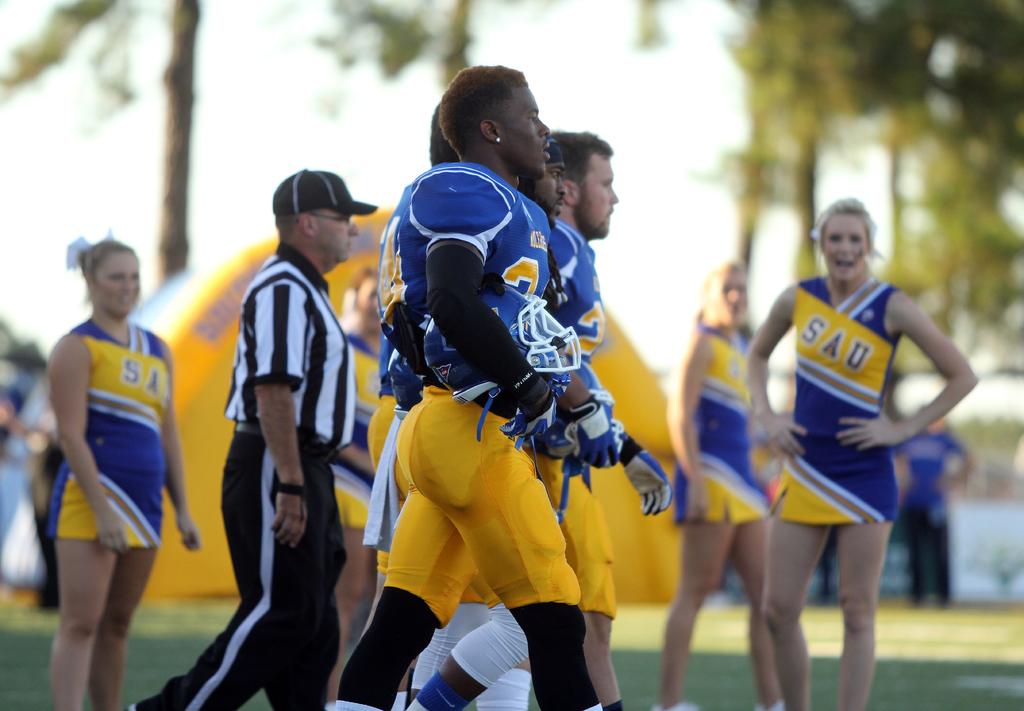Do these players go to sau?
Keep it short and to the point. Yes. What school do the cheerleaders cheer for?
Offer a terse response. Sau. 